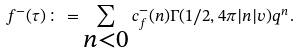Convert formula to latex. <formula><loc_0><loc_0><loc_500><loc_500>f ^ { - } ( \tau ) \colon = \sum _ { \substack { n < 0 } } c _ { f } ^ { - } ( n ) \Gamma ( 1 / 2 , 4 \pi | n | v ) q ^ { n } .</formula> 